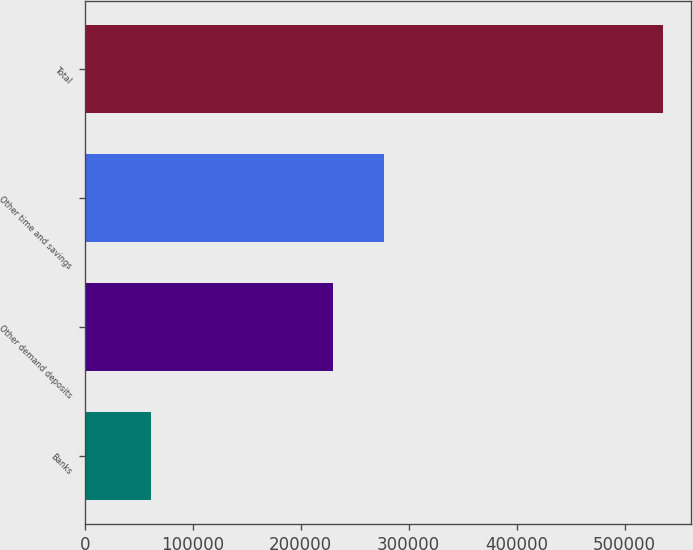Convert chart. <chart><loc_0><loc_0><loc_500><loc_500><bar_chart><fcel>Banks<fcel>Other demand deposits<fcel>Other time and savings<fcel>Total<nl><fcel>61705<fcel>229880<fcel>277231<fcel>535215<nl></chart> 